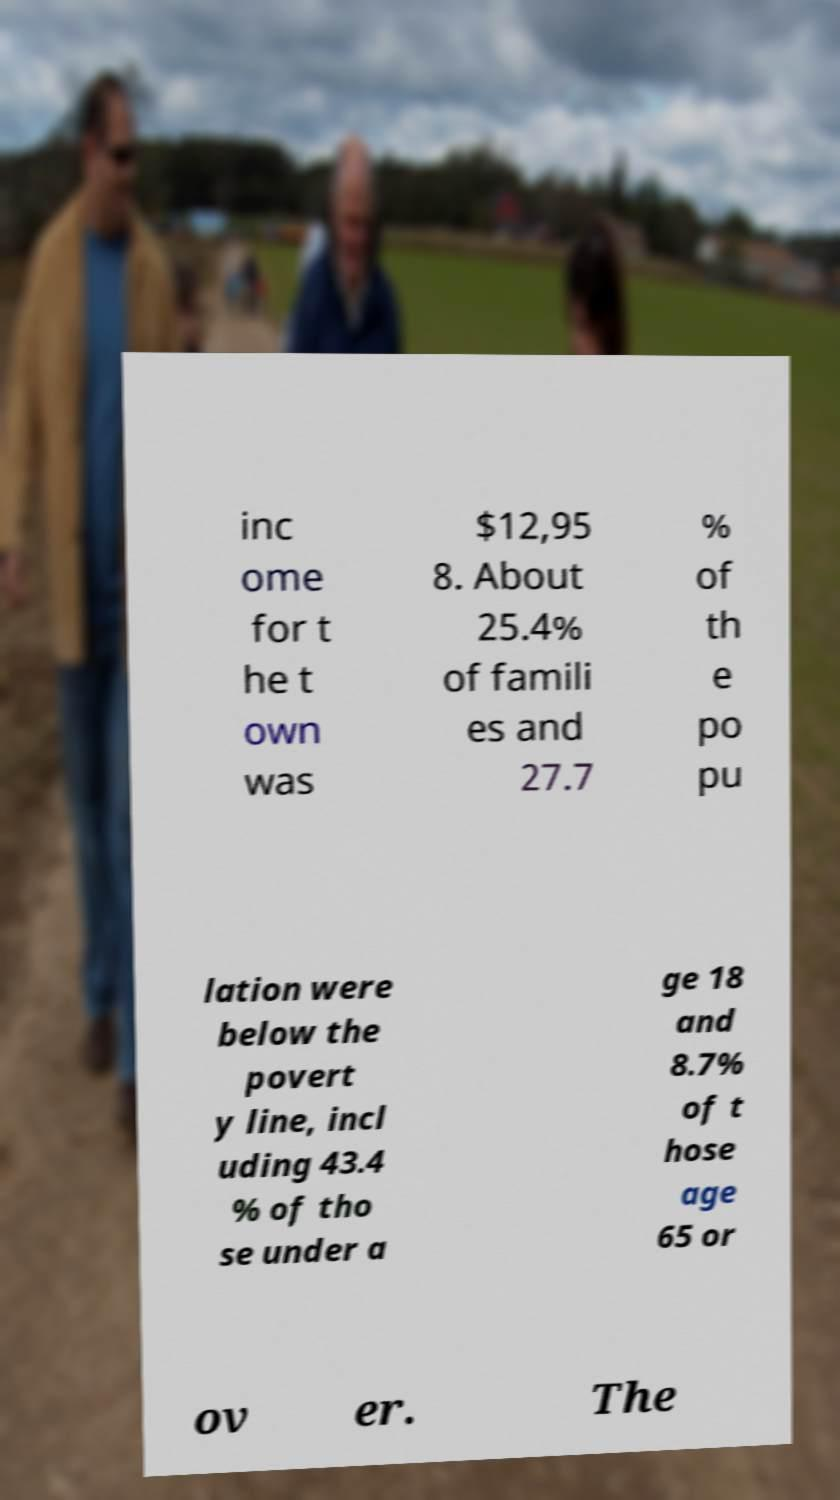Can you accurately transcribe the text from the provided image for me? inc ome for t he t own was $12,95 8. About 25.4% of famili es and 27.7 % of th e po pu lation were below the povert y line, incl uding 43.4 % of tho se under a ge 18 and 8.7% of t hose age 65 or ov er. The 